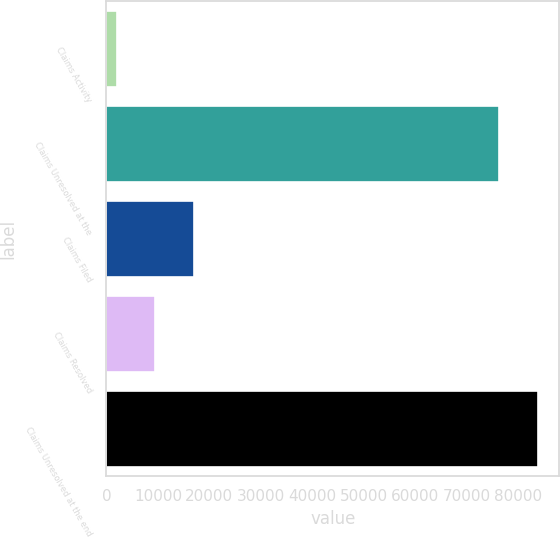<chart> <loc_0><loc_0><loc_500><loc_500><bar_chart><fcel>Claims Activity<fcel>Claims Unresolved at the<fcel>Claims Filed<fcel>Claims Resolved<fcel>Claims Unresolved at the end<nl><fcel>2005<fcel>76348<fcel>16999.6<fcel>9502.3<fcel>83845.3<nl></chart> 